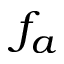<formula> <loc_0><loc_0><loc_500><loc_500>f _ { a }</formula> 